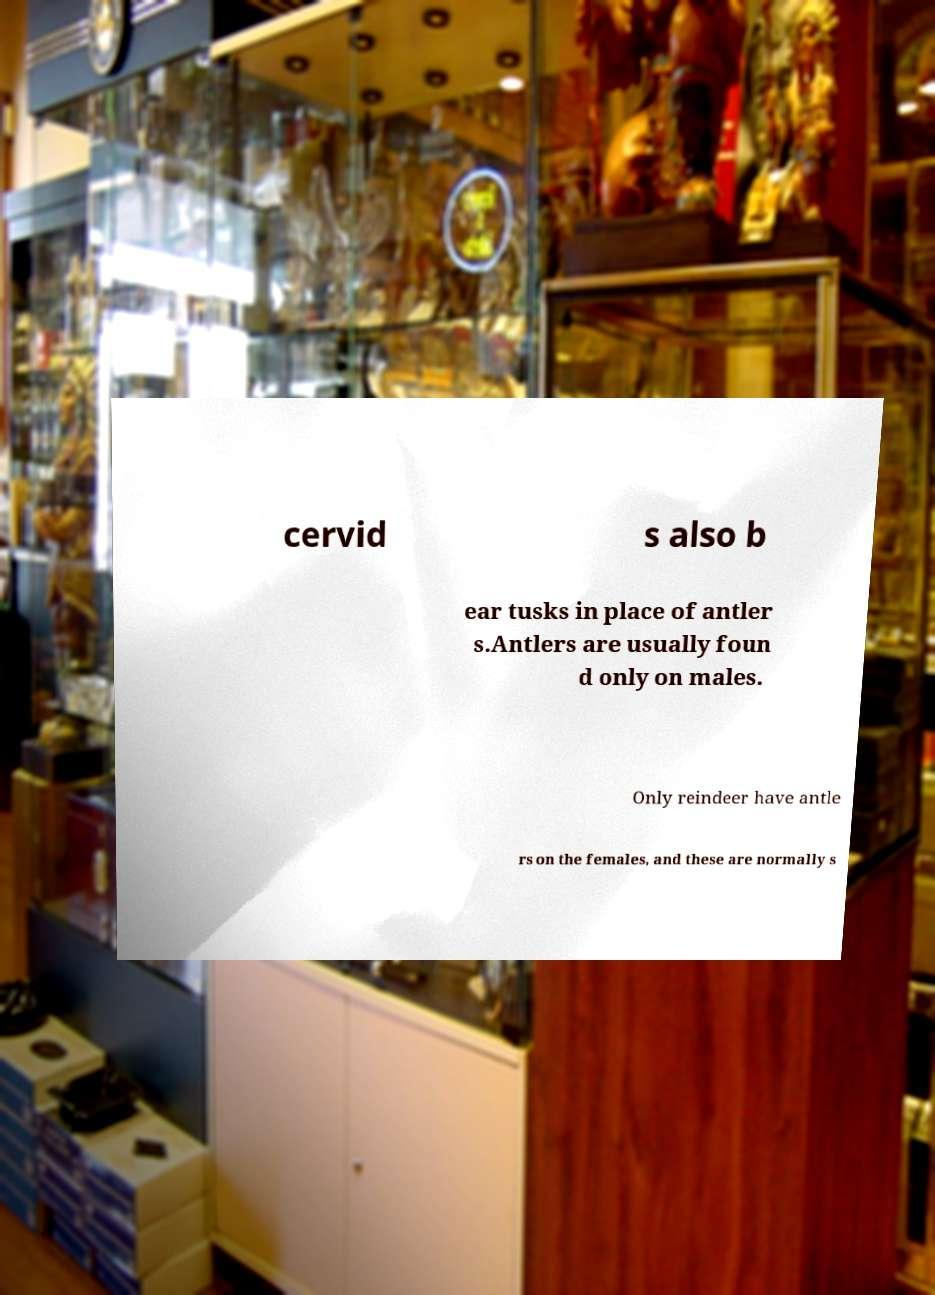Can you read and provide the text displayed in the image?This photo seems to have some interesting text. Can you extract and type it out for me? cervid s also b ear tusks in place of antler s.Antlers are usually foun d only on males. Only reindeer have antle rs on the females, and these are normally s 